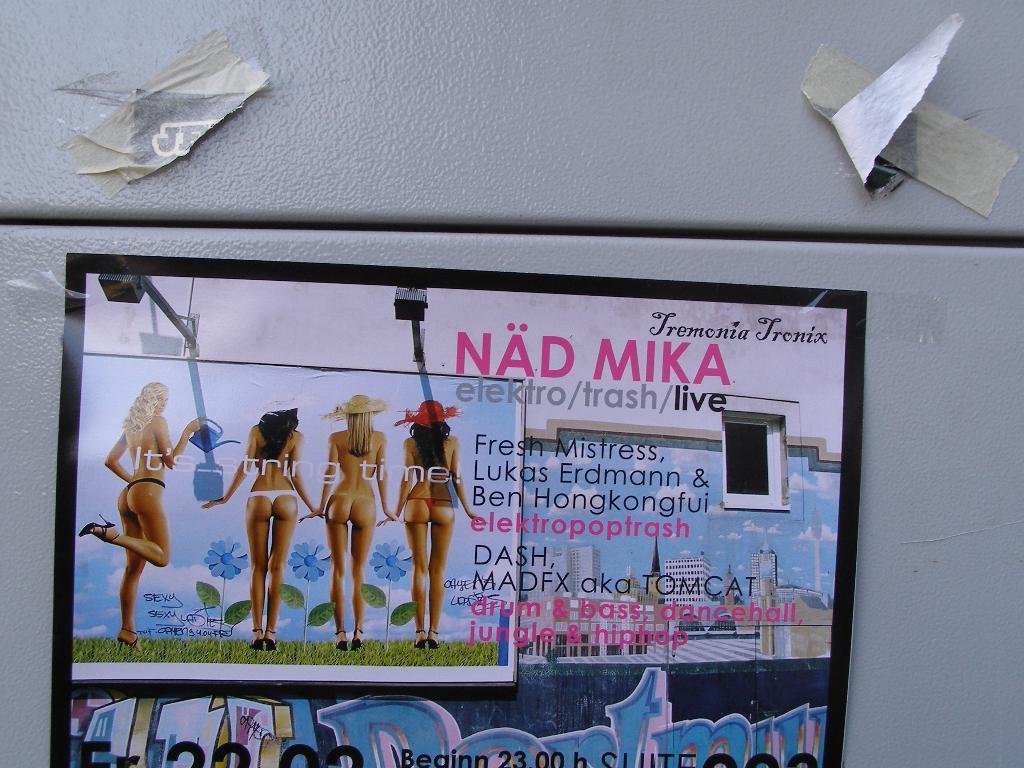Can you describe this image briefly? In this picture I can see a poster in the middle, on the left side few women are standing, on the right side there is the text. At the top there are paper pieces. 